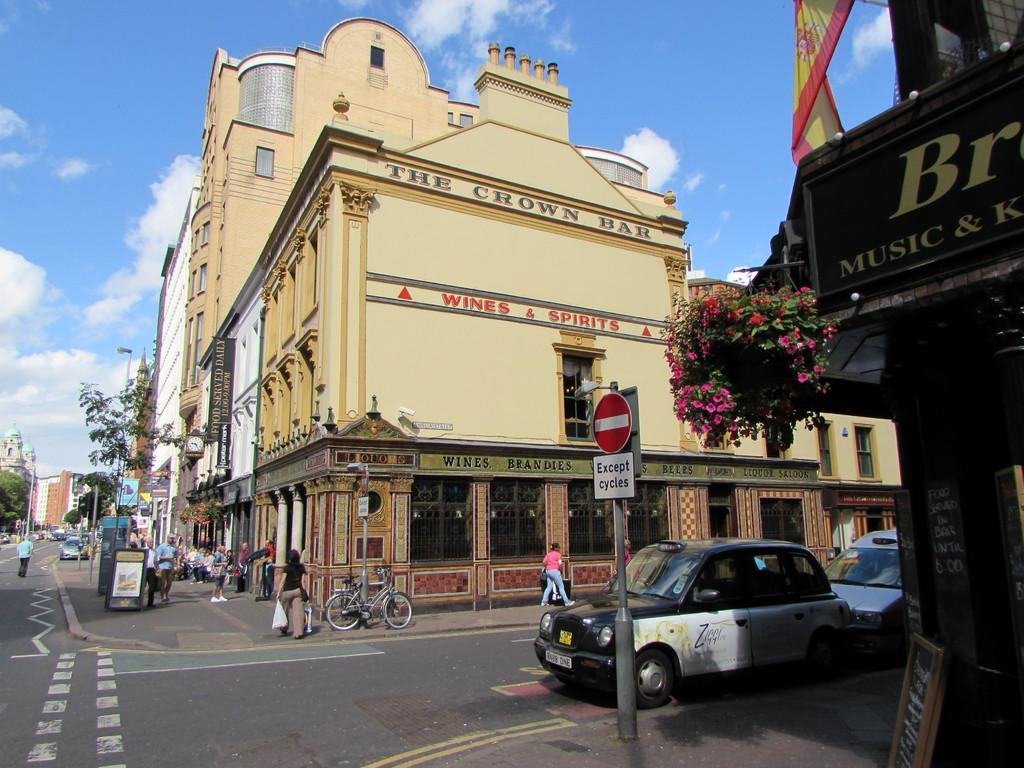<image>
Render a clear and concise summary of the photo. A street sign with a cream building with 'the Crown Bar' written on it. 